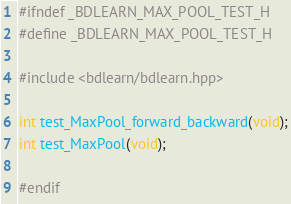Convert code to text. <code><loc_0><loc_0><loc_500><loc_500><_C++_>#ifndef _BDLEARN_MAX_POOL_TEST_H
#define _BDLEARN_MAX_POOL_TEST_H

#include <bdlearn/bdlearn.hpp>

int test_MaxPool_forward_backward(void);
int test_MaxPool(void);

#endif</code> 